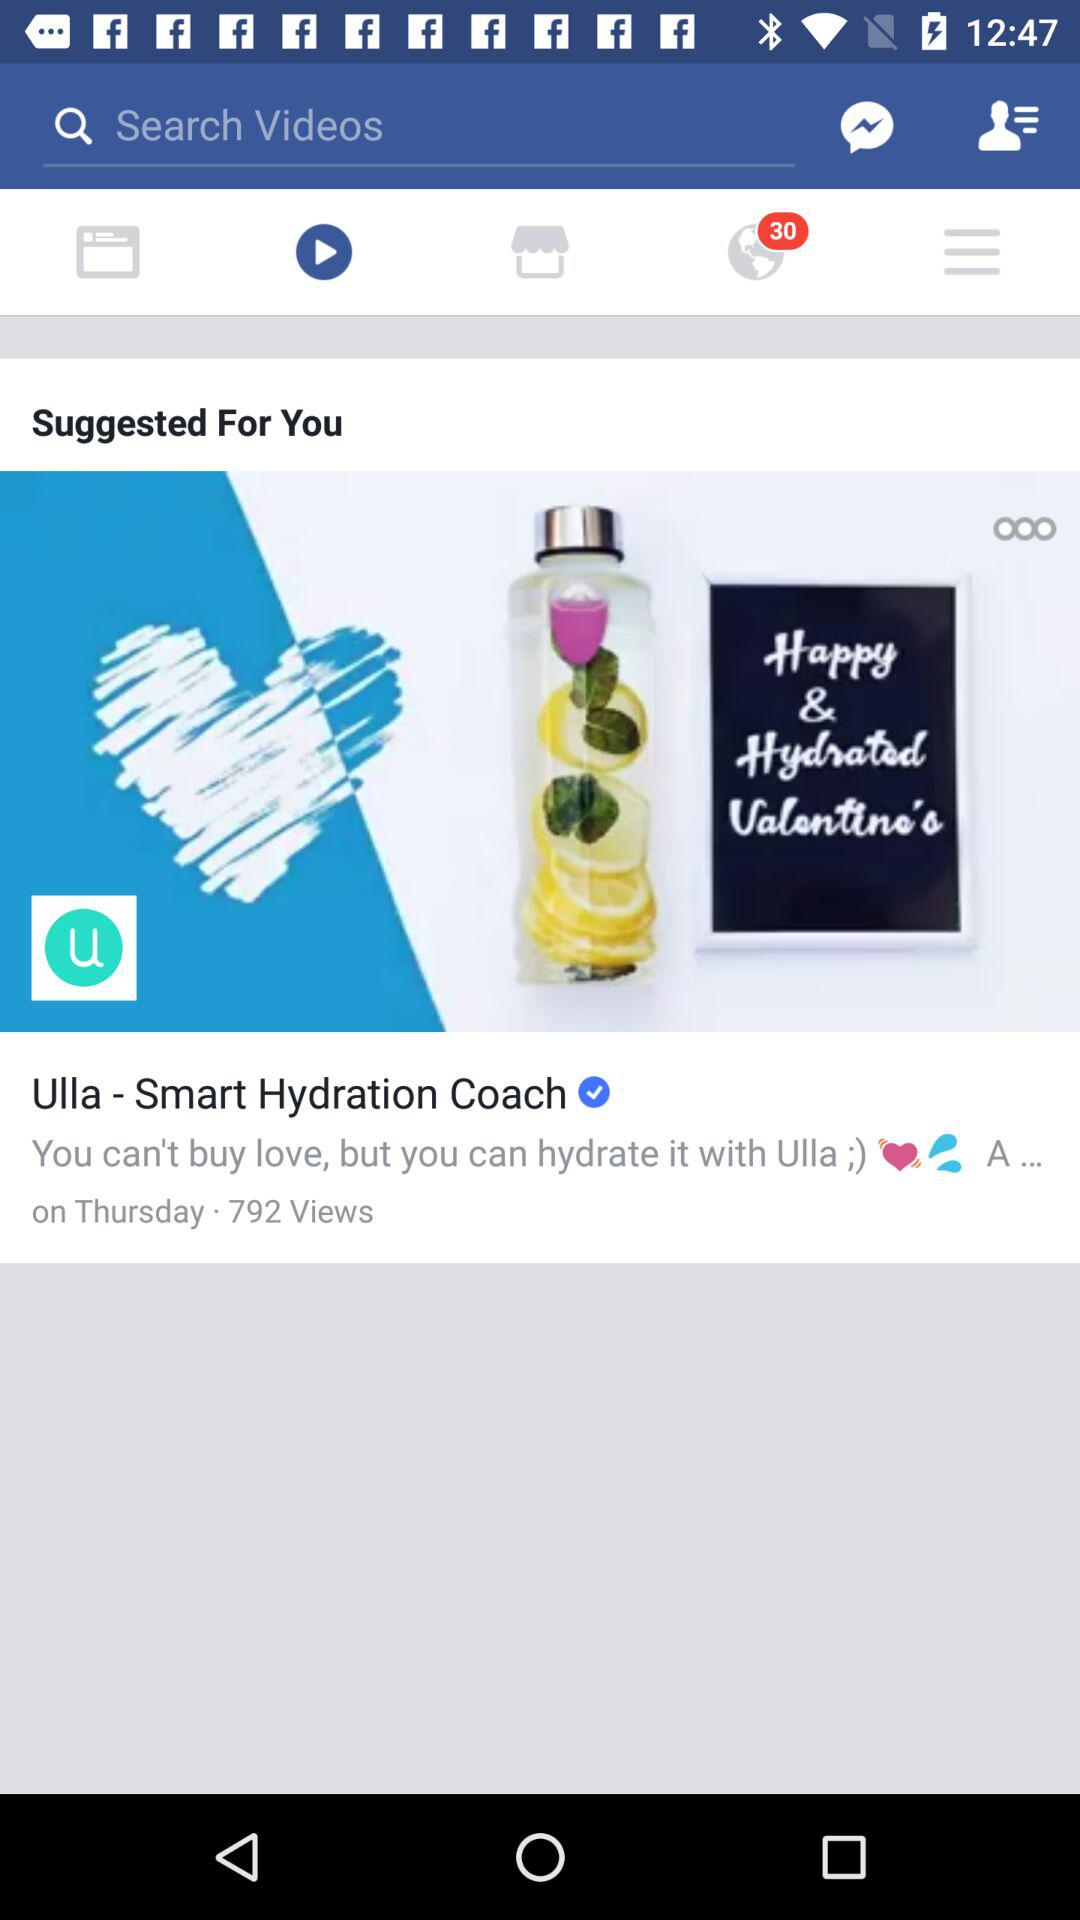How many notifications are there? There are 30 notifications. 